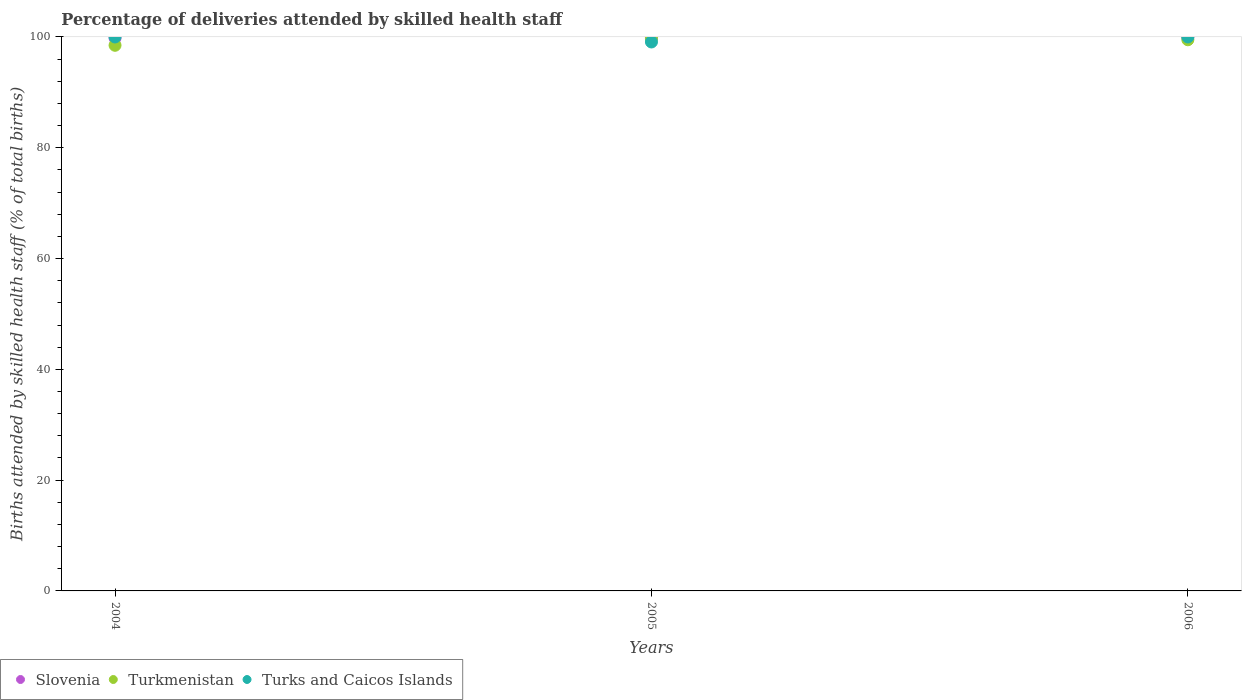What is the percentage of births attended by skilled health staff in Slovenia in 2004?
Ensure brevity in your answer.  99.8. Across all years, what is the maximum percentage of births attended by skilled health staff in Turkmenistan?
Ensure brevity in your answer.  99.7. Across all years, what is the minimum percentage of births attended by skilled health staff in Slovenia?
Make the answer very short. 99.8. In which year was the percentage of births attended by skilled health staff in Turkmenistan maximum?
Your answer should be compact. 2005. In which year was the percentage of births attended by skilled health staff in Turkmenistan minimum?
Make the answer very short. 2004. What is the total percentage of births attended by skilled health staff in Turkmenistan in the graph?
Keep it short and to the point. 297.7. What is the difference between the percentage of births attended by skilled health staff in Turkmenistan in 2005 and that in 2006?
Provide a short and direct response. 0.2. What is the difference between the percentage of births attended by skilled health staff in Turks and Caicos Islands in 2006 and the percentage of births attended by skilled health staff in Slovenia in 2004?
Ensure brevity in your answer.  0.2. What is the average percentage of births attended by skilled health staff in Slovenia per year?
Keep it short and to the point. 99.87. In the year 2004, what is the difference between the percentage of births attended by skilled health staff in Slovenia and percentage of births attended by skilled health staff in Turks and Caicos Islands?
Your response must be concise. -0.2. What is the ratio of the percentage of births attended by skilled health staff in Turks and Caicos Islands in 2004 to that in 2005?
Make the answer very short. 1.01. What is the difference between the highest and the second highest percentage of births attended by skilled health staff in Turkmenistan?
Offer a terse response. 0.2. What is the difference between the highest and the lowest percentage of births attended by skilled health staff in Turkmenistan?
Make the answer very short. 1.2. Is the sum of the percentage of births attended by skilled health staff in Turkmenistan in 2005 and 2006 greater than the maximum percentage of births attended by skilled health staff in Slovenia across all years?
Provide a short and direct response. Yes. Is it the case that in every year, the sum of the percentage of births attended by skilled health staff in Turks and Caicos Islands and percentage of births attended by skilled health staff in Turkmenistan  is greater than the percentage of births attended by skilled health staff in Slovenia?
Your response must be concise. Yes. Does the percentage of births attended by skilled health staff in Turkmenistan monotonically increase over the years?
Give a very brief answer. No. Is the percentage of births attended by skilled health staff in Slovenia strictly greater than the percentage of births attended by skilled health staff in Turkmenistan over the years?
Your answer should be compact. Yes. What is the difference between two consecutive major ticks on the Y-axis?
Your response must be concise. 20. How many legend labels are there?
Your answer should be compact. 3. How are the legend labels stacked?
Make the answer very short. Horizontal. What is the title of the graph?
Provide a succinct answer. Percentage of deliveries attended by skilled health staff. Does "Lesotho" appear as one of the legend labels in the graph?
Your answer should be very brief. No. What is the label or title of the Y-axis?
Ensure brevity in your answer.  Births attended by skilled health staff (% of total births). What is the Births attended by skilled health staff (% of total births) in Slovenia in 2004?
Your answer should be very brief. 99.8. What is the Births attended by skilled health staff (% of total births) in Turkmenistan in 2004?
Offer a terse response. 98.5. What is the Births attended by skilled health staff (% of total births) of Turks and Caicos Islands in 2004?
Offer a terse response. 100. What is the Births attended by skilled health staff (% of total births) of Slovenia in 2005?
Your response must be concise. 99.9. What is the Births attended by skilled health staff (% of total births) of Turkmenistan in 2005?
Your response must be concise. 99.7. What is the Births attended by skilled health staff (% of total births) in Turks and Caicos Islands in 2005?
Offer a terse response. 99.1. What is the Births attended by skilled health staff (% of total births) in Slovenia in 2006?
Provide a short and direct response. 99.9. What is the Births attended by skilled health staff (% of total births) of Turkmenistan in 2006?
Offer a terse response. 99.5. Across all years, what is the maximum Births attended by skilled health staff (% of total births) of Slovenia?
Provide a short and direct response. 99.9. Across all years, what is the maximum Births attended by skilled health staff (% of total births) in Turkmenistan?
Offer a terse response. 99.7. Across all years, what is the maximum Births attended by skilled health staff (% of total births) of Turks and Caicos Islands?
Make the answer very short. 100. Across all years, what is the minimum Births attended by skilled health staff (% of total births) in Slovenia?
Offer a very short reply. 99.8. Across all years, what is the minimum Births attended by skilled health staff (% of total births) of Turkmenistan?
Ensure brevity in your answer.  98.5. Across all years, what is the minimum Births attended by skilled health staff (% of total births) in Turks and Caicos Islands?
Your response must be concise. 99.1. What is the total Births attended by skilled health staff (% of total births) of Slovenia in the graph?
Give a very brief answer. 299.6. What is the total Births attended by skilled health staff (% of total births) of Turkmenistan in the graph?
Offer a very short reply. 297.7. What is the total Births attended by skilled health staff (% of total births) in Turks and Caicos Islands in the graph?
Your response must be concise. 299.1. What is the difference between the Births attended by skilled health staff (% of total births) of Turkmenistan in 2004 and that in 2005?
Make the answer very short. -1.2. What is the difference between the Births attended by skilled health staff (% of total births) of Slovenia in 2004 and that in 2006?
Provide a succinct answer. -0.1. What is the difference between the Births attended by skilled health staff (% of total births) of Turkmenistan in 2004 and that in 2006?
Keep it short and to the point. -1. What is the difference between the Births attended by skilled health staff (% of total births) of Turks and Caicos Islands in 2004 and that in 2006?
Your answer should be compact. 0. What is the difference between the Births attended by skilled health staff (% of total births) of Turkmenistan in 2004 and the Births attended by skilled health staff (% of total births) of Turks and Caicos Islands in 2005?
Provide a succinct answer. -0.6. What is the average Births attended by skilled health staff (% of total births) in Slovenia per year?
Your answer should be compact. 99.87. What is the average Births attended by skilled health staff (% of total births) in Turkmenistan per year?
Provide a short and direct response. 99.23. What is the average Births attended by skilled health staff (% of total births) in Turks and Caicos Islands per year?
Your answer should be very brief. 99.7. In the year 2004, what is the difference between the Births attended by skilled health staff (% of total births) of Turkmenistan and Births attended by skilled health staff (% of total births) of Turks and Caicos Islands?
Give a very brief answer. -1.5. In the year 2005, what is the difference between the Births attended by skilled health staff (% of total births) of Slovenia and Births attended by skilled health staff (% of total births) of Turkmenistan?
Offer a terse response. 0.2. In the year 2006, what is the difference between the Births attended by skilled health staff (% of total births) in Slovenia and Births attended by skilled health staff (% of total births) in Turkmenistan?
Offer a very short reply. 0.4. What is the ratio of the Births attended by skilled health staff (% of total births) in Turkmenistan in 2004 to that in 2005?
Offer a terse response. 0.99. What is the ratio of the Births attended by skilled health staff (% of total births) of Turks and Caicos Islands in 2004 to that in 2005?
Keep it short and to the point. 1.01. What is the ratio of the Births attended by skilled health staff (% of total births) in Slovenia in 2004 to that in 2006?
Offer a very short reply. 1. What is the ratio of the Births attended by skilled health staff (% of total births) of Turkmenistan in 2004 to that in 2006?
Make the answer very short. 0.99. What is the ratio of the Births attended by skilled health staff (% of total births) in Turks and Caicos Islands in 2004 to that in 2006?
Offer a very short reply. 1. What is the ratio of the Births attended by skilled health staff (% of total births) of Slovenia in 2005 to that in 2006?
Give a very brief answer. 1. What is the difference between the highest and the second highest Births attended by skilled health staff (% of total births) of Slovenia?
Give a very brief answer. 0. What is the difference between the highest and the second highest Births attended by skilled health staff (% of total births) in Turkmenistan?
Ensure brevity in your answer.  0.2. What is the difference between the highest and the lowest Births attended by skilled health staff (% of total births) of Turkmenistan?
Your response must be concise. 1.2. What is the difference between the highest and the lowest Births attended by skilled health staff (% of total births) of Turks and Caicos Islands?
Your response must be concise. 0.9. 